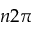Convert formula to latex. <formula><loc_0><loc_0><loc_500><loc_500>n 2 \pi</formula> 